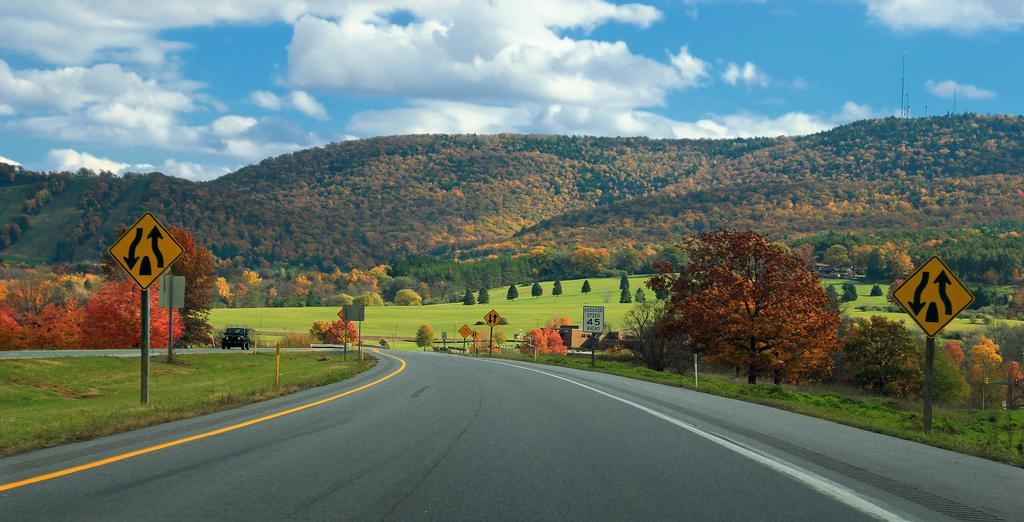Can you describe this image briefly? In this image I can see sign boards, vehicle on the road and the grass. In the background I can see trees, hills and the sky. 